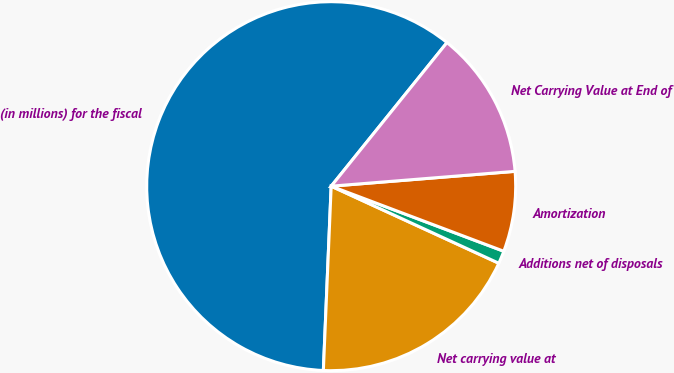Convert chart to OTSL. <chart><loc_0><loc_0><loc_500><loc_500><pie_chart><fcel>(in millions) for the fiscal<fcel>Net carrying value at<fcel>Additions net of disposals<fcel>Amortization<fcel>Net Carrying Value at End of<nl><fcel>60.13%<fcel>18.82%<fcel>1.12%<fcel>7.02%<fcel>12.92%<nl></chart> 